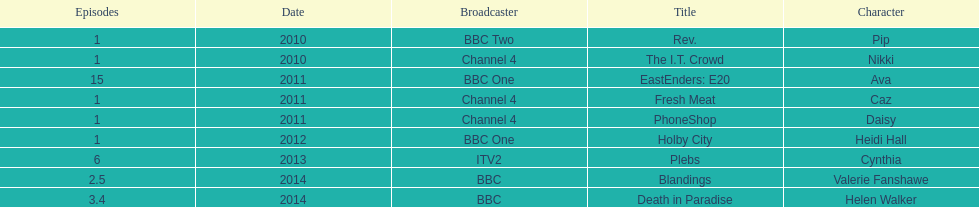Can you give me this table as a dict? {'header': ['Episodes', 'Date', 'Broadcaster', 'Title', 'Character'], 'rows': [['1', '2010', 'BBC Two', 'Rev.', 'Pip'], ['1', '2010', 'Channel 4', 'The I.T. Crowd', 'Nikki'], ['15', '2011', 'BBC One', 'EastEnders: E20', 'Ava'], ['1', '2011', 'Channel 4', 'Fresh Meat', 'Caz'], ['1', '2011', 'Channel 4', 'PhoneShop', 'Daisy'], ['1', '2012', 'BBC One', 'Holby City', 'Heidi Hall'], ['6', '2013', 'ITV2', 'Plebs', 'Cynthia'], ['2.5', '2014', 'BBC', 'Blandings', 'Valerie Fanshawe'], ['3.4', '2014', 'BBC', 'Death in Paradise', 'Helen Walker']]} How many titles only had one episode? 5. 